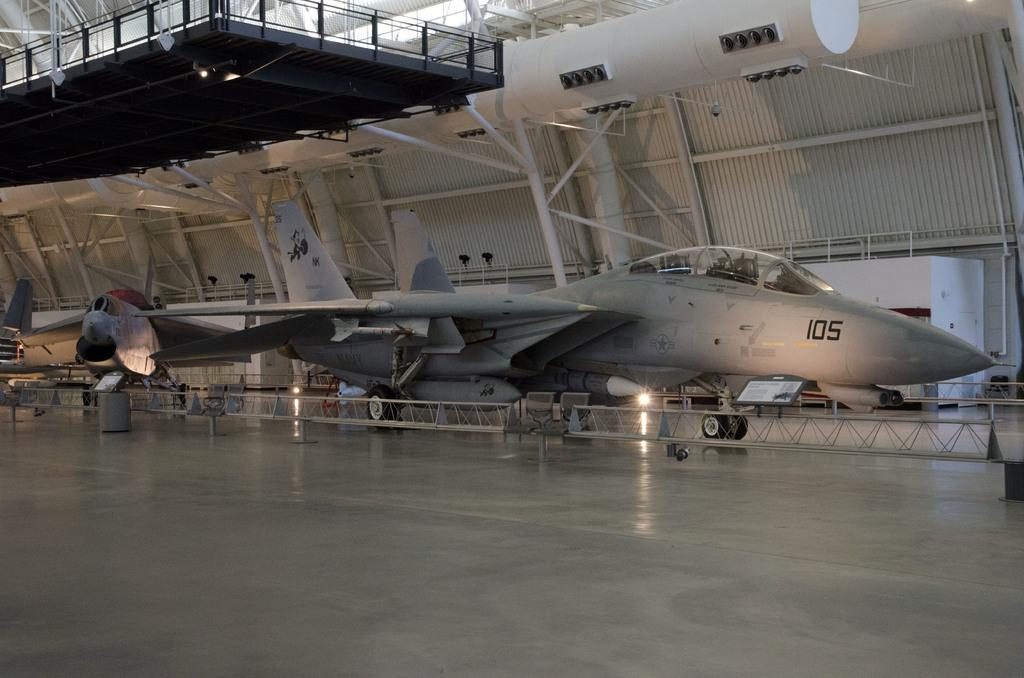<image>
Offer a succinct explanation of the picture presented. A grey fighter jet with the number 105 on it is parked in a hangar. 